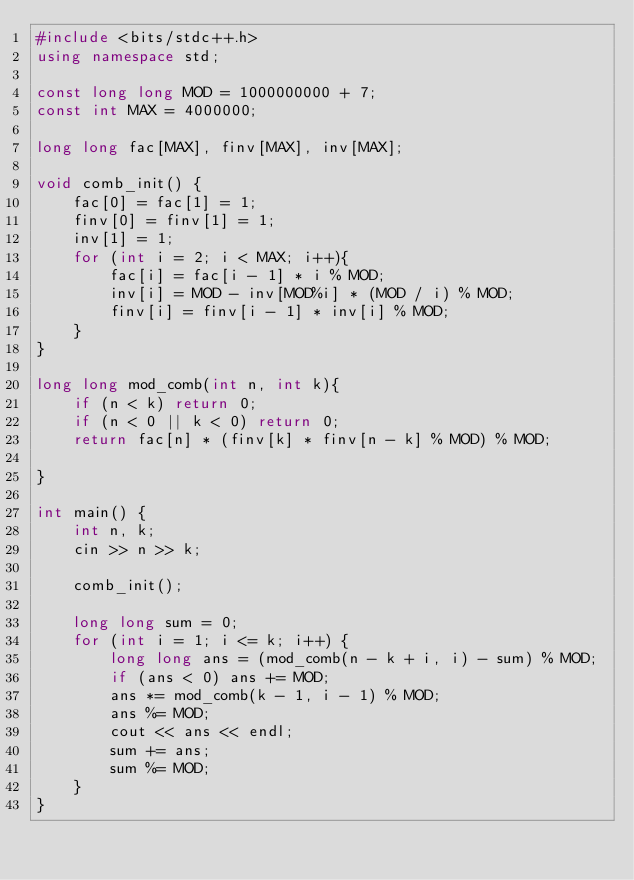<code> <loc_0><loc_0><loc_500><loc_500><_C++_>#include <bits/stdc++.h>
using namespace std;

const long long MOD = 1000000000 + 7;
const int MAX = 4000000;

long long fac[MAX], finv[MAX], inv[MAX];

void comb_init() {
    fac[0] = fac[1] = 1;
    finv[0] = finv[1] = 1;
    inv[1] = 1;
    for (int i = 2; i < MAX; i++){
        fac[i] = fac[i - 1] * i % MOD;
        inv[i] = MOD - inv[MOD%i] * (MOD / i) % MOD;
        finv[i] = finv[i - 1] * inv[i] % MOD;
    }
}

long long mod_comb(int n, int k){
    if (n < k) return 0;
    if (n < 0 || k < 0) return 0;
    return fac[n] * (finv[k] * finv[n - k] % MOD) % MOD;

}

int main() {
    int n, k;
    cin >> n >> k;

    comb_init();
    
    long long sum = 0;
    for (int i = 1; i <= k; i++) {
        long long ans = (mod_comb(n - k + i, i) - sum) % MOD;
        if (ans < 0) ans += MOD;
        ans *= mod_comb(k - 1, i - 1) % MOD;
        ans %= MOD;
        cout << ans << endl;
        sum += ans;
        sum %= MOD;
    }
}</code> 